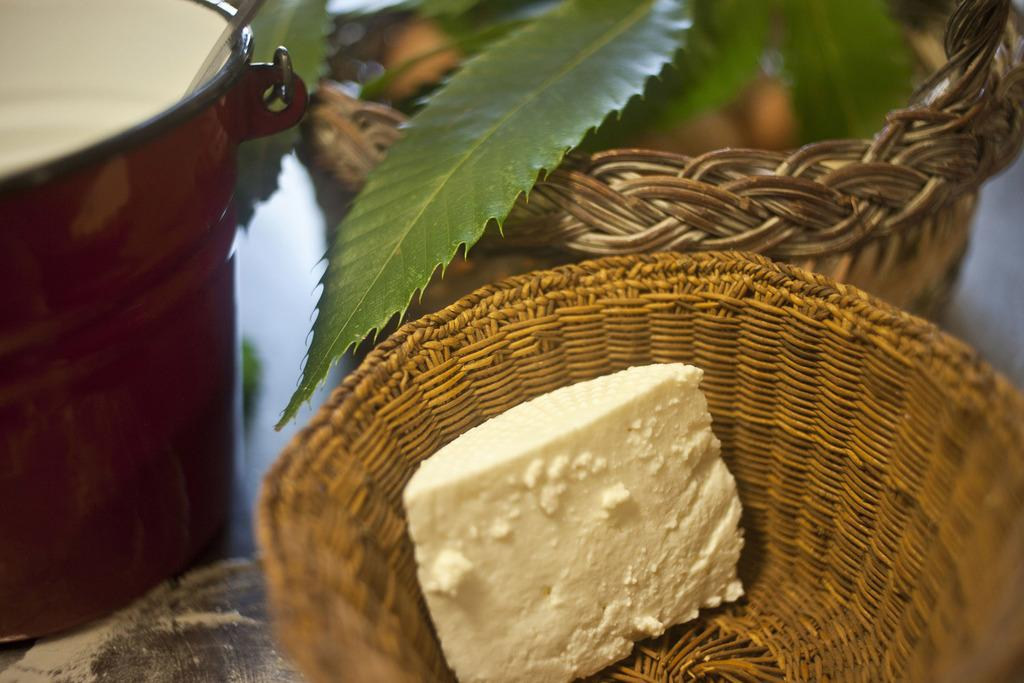What type of sweet can be seen in the image? There is a sweet in the image, but the specific type is not mentioned. How is the sweet stored or displayed in the image? The sweet is kept in a basket in the image. What other container is present in the image? There is a bucket in the image. Are there any additional baskets in the image? Yes, there is a second basket in the image. What type of tin can be seen in the image? There is no tin present in the image. What kind of machine is used to create the sweet in the image? The image does not show the process of creating the sweet or any machines involved in its production. 